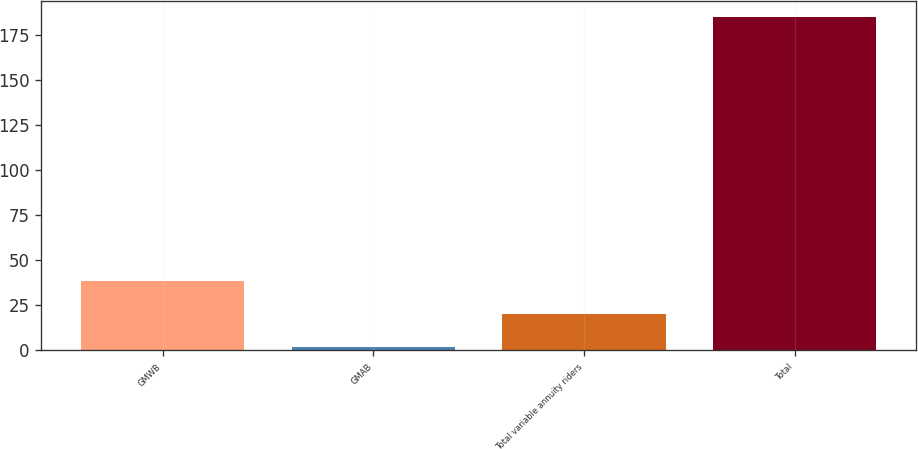Convert chart. <chart><loc_0><loc_0><loc_500><loc_500><bar_chart><fcel>GMWB<fcel>GMAB<fcel>Total variable annuity riders<fcel>Total<nl><fcel>38.6<fcel>2<fcel>20.3<fcel>185<nl></chart> 